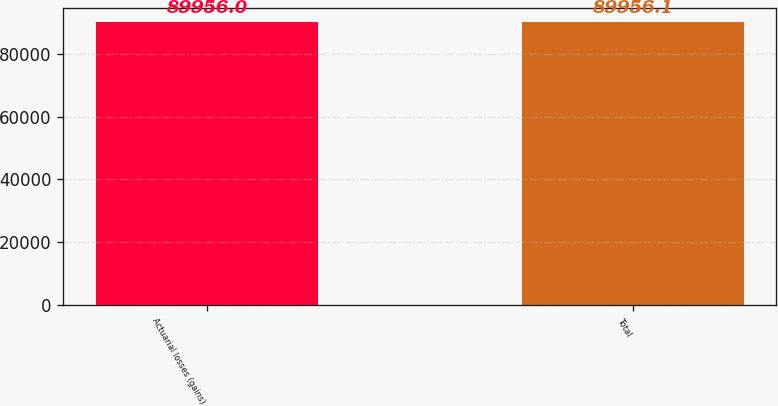Convert chart to OTSL. <chart><loc_0><loc_0><loc_500><loc_500><bar_chart><fcel>Actuarial losses (gains)<fcel>Total<nl><fcel>89956<fcel>89956.1<nl></chart> 